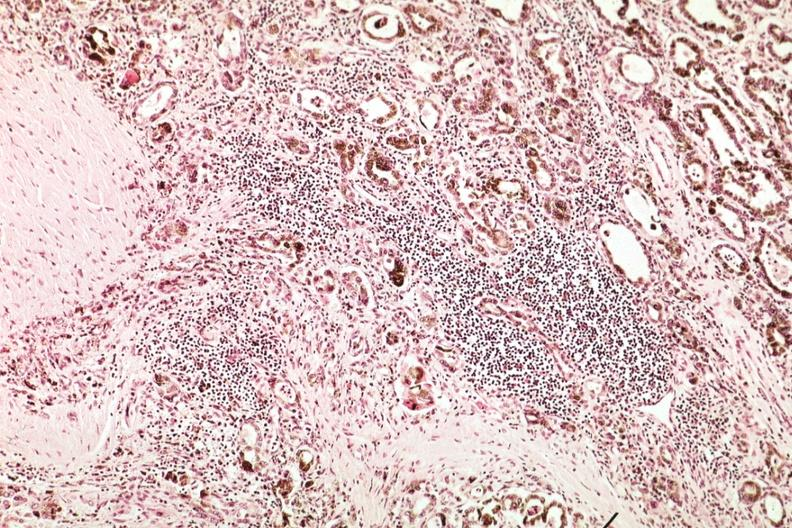how does this image show marked atrophy?
Answer the question using a single word or phrase. With iron in epithelium and lymphocytic infiltrate 